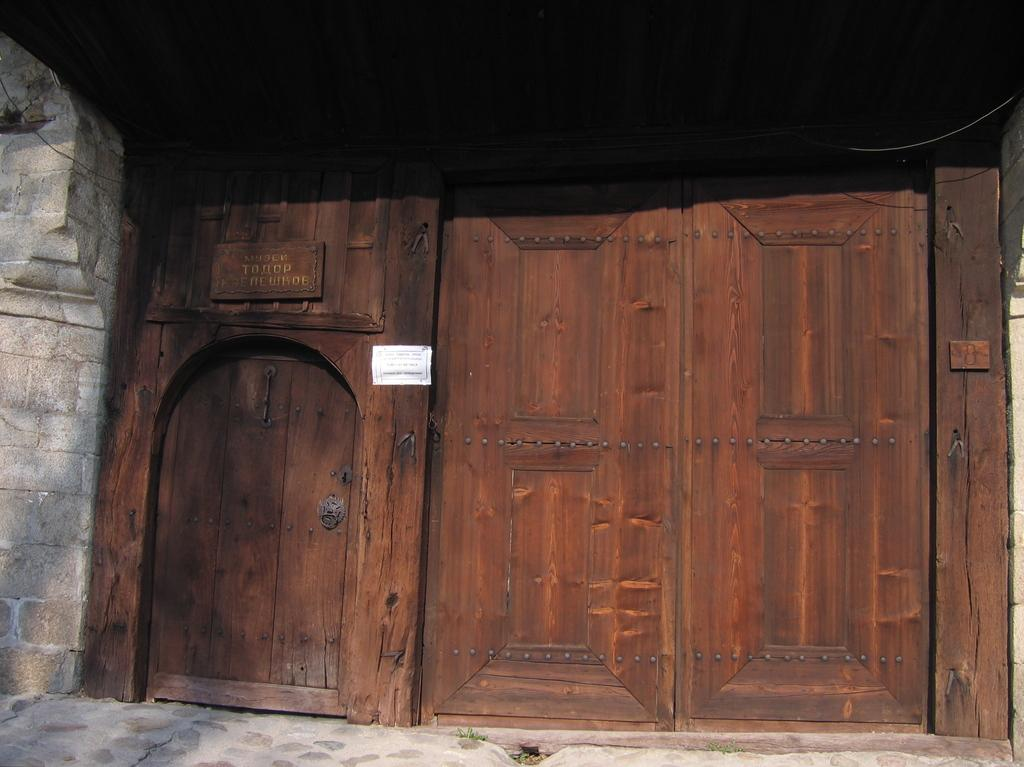What is the main object in the image? There is a door in the image. What is attached to the door? There is a board on the door. What is written on the board? There is a paper with text on it on the board. What can be seen on the left side of the image? There is a wall on the left side of the image. Is there a river flowing in front of the door in the image? There is no river present in the image; it only features a door, a board, a paper with text, and a wall. 